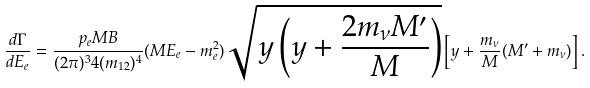Convert formula to latex. <formula><loc_0><loc_0><loc_500><loc_500>\frac { d \Gamma } { d E _ { e } } = \frac { p _ { e } M B } { ( 2 \pi ) ^ { 3 } 4 ( m _ { 1 2 } ) ^ { 4 } } ( M E _ { e } - m _ { e } ^ { 2 } ) \sqrt { y \left ( y + \frac { 2 m _ { \nu } M ^ { \prime } } { M } \right ) } \left [ y + \frac { m _ { \nu } } { M } ( M ^ { \prime } + m _ { \nu } ) \right ] .</formula> 